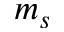<formula> <loc_0><loc_0><loc_500><loc_500>m _ { s }</formula> 